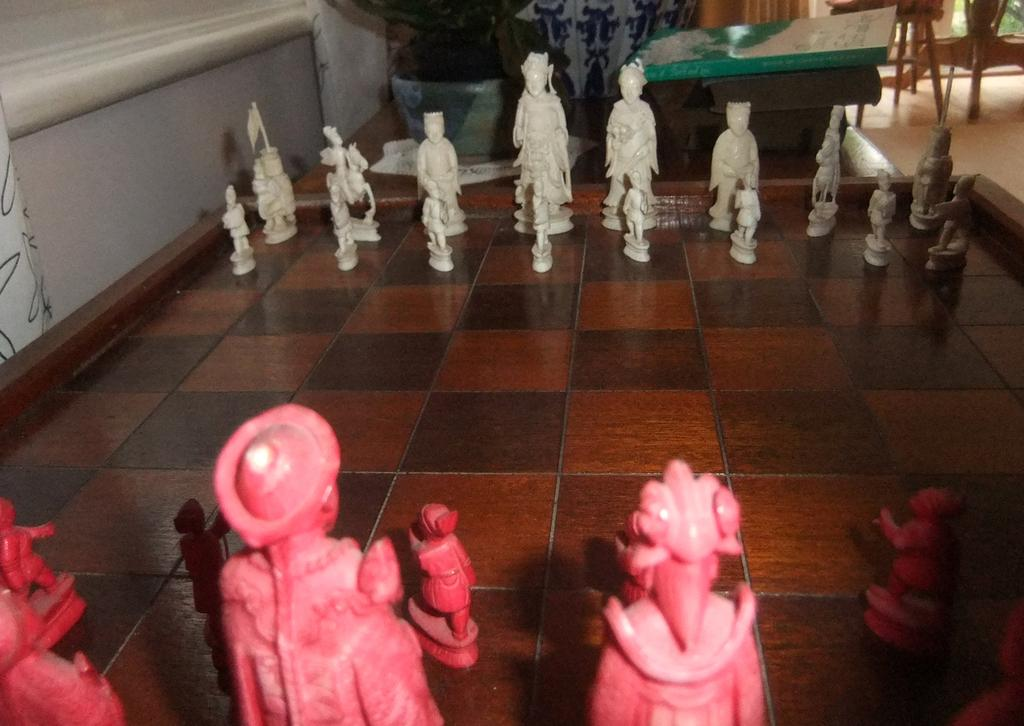What game is being played on the chess board in the image? The game being played on the chess board in the image is chess. What pieces are used in the game of chess? In the image, there are chess coins on the chess board. What can be seen in the background of the image? In the background of the image, there is a book and other items visible. What type of wine is being served to the boys in the image? There are no boys or wine present in the image; it features a chess board with chess coins and a background with a book and other items. 